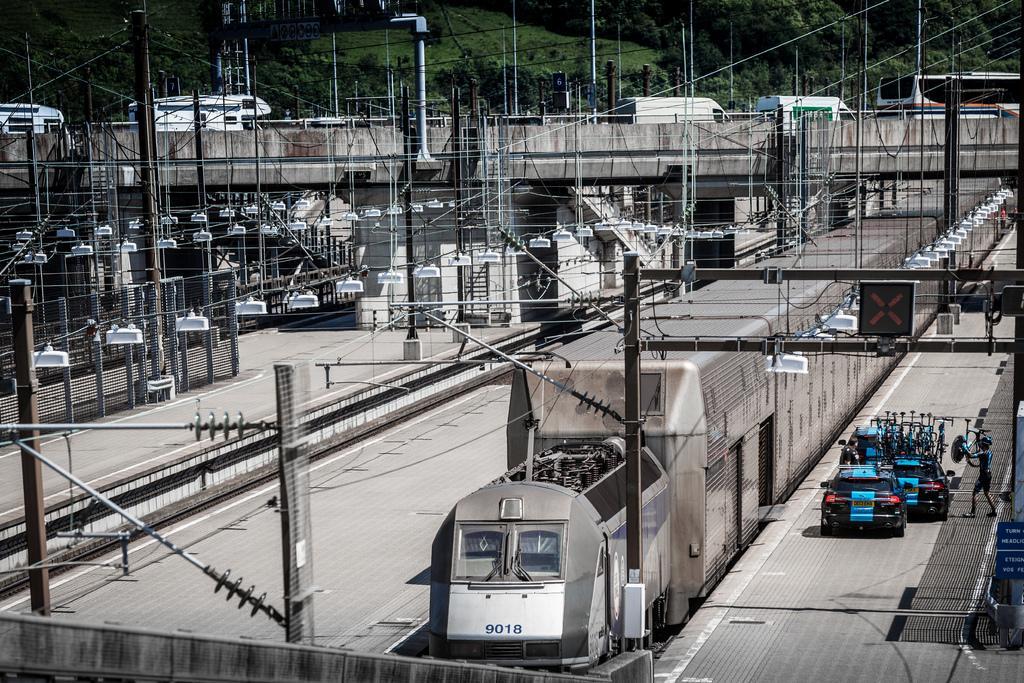Could you give a brief overview of what you see in this image? At the bottom, we see a train moving on the railway tracks. On the right side, we see the cars in black and blue color. Beside that, we see a person is standing. On the left side, we see the electric poles, wires and the transformers. In the middle, we see the vehicles are moving on the bridge. There are trees, poles and the wires in the background. 